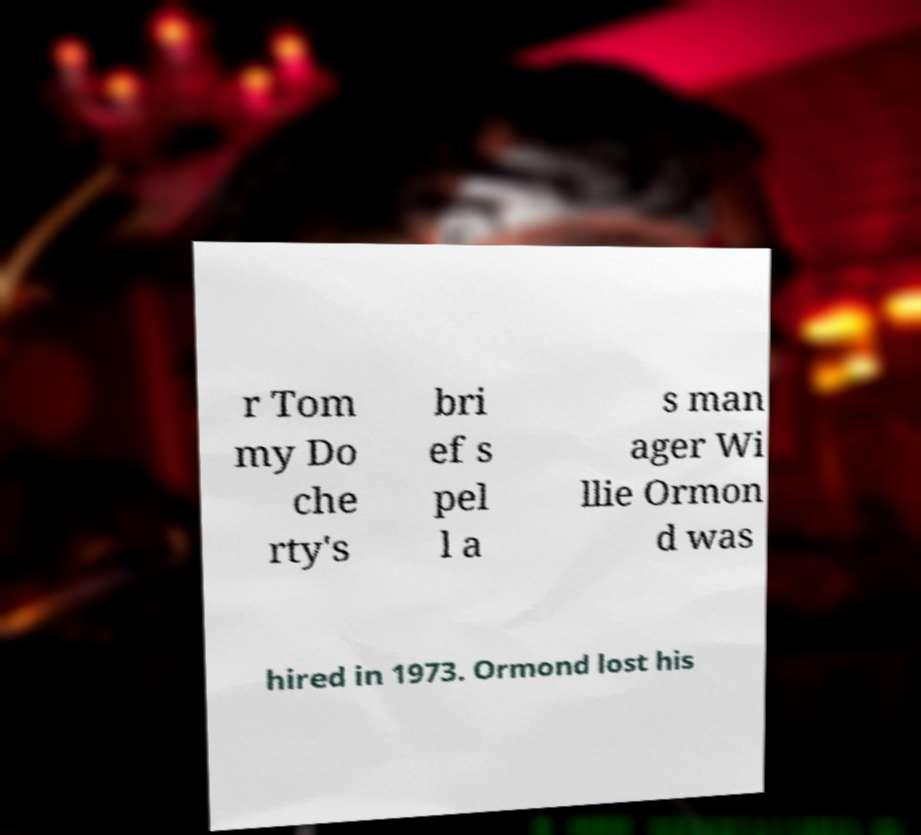Can you read and provide the text displayed in the image?This photo seems to have some interesting text. Can you extract and type it out for me? r Tom my Do che rty's bri ef s pel l a s man ager Wi llie Ormon d was hired in 1973. Ormond lost his 